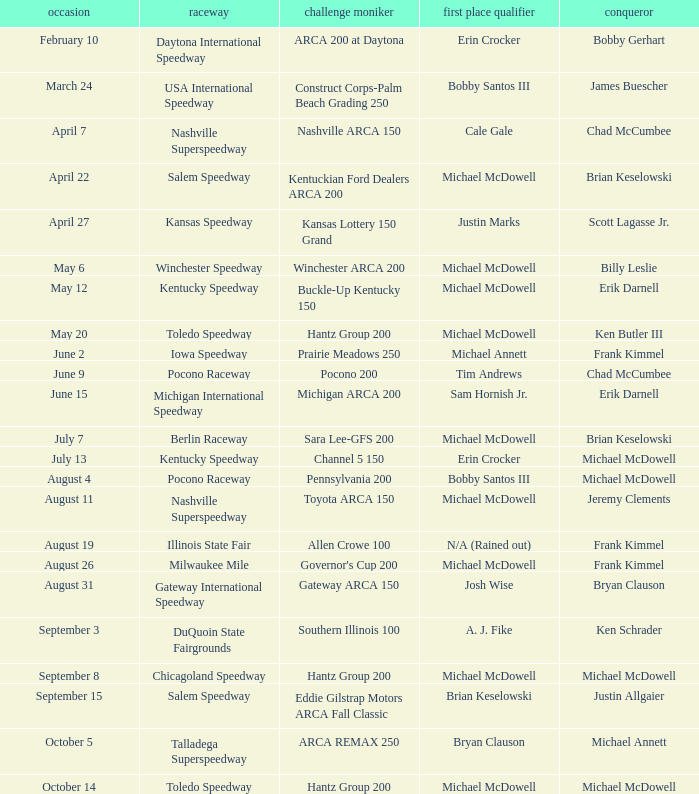Tell me the track for june 9 Pocono Raceway. 